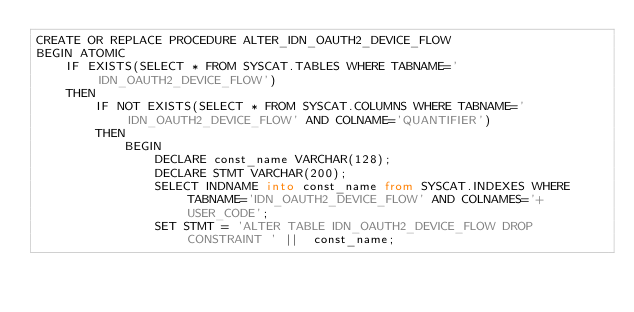Convert code to text. <code><loc_0><loc_0><loc_500><loc_500><_SQL_>CREATE OR REPLACE PROCEDURE ALTER_IDN_OAUTH2_DEVICE_FLOW
BEGIN ATOMIC
    IF EXISTS(SELECT * FROM SYSCAT.TABLES WHERE TABNAME='IDN_OAUTH2_DEVICE_FLOW')
    THEN
        IF NOT EXISTS(SELECT * FROM SYSCAT.COLUMNS WHERE TABNAME='IDN_OAUTH2_DEVICE_FLOW' AND COLNAME='QUANTIFIER')
        THEN
            BEGIN
                DECLARE const_name VARCHAR(128);
                DECLARE STMT VARCHAR(200);
                SELECT INDNAME into const_name from SYSCAT.INDEXES WHERE TABNAME='IDN_OAUTH2_DEVICE_FLOW' AND COLNAMES='+USER_CODE';
                SET STMT = 'ALTER TABLE IDN_OAUTH2_DEVICE_FLOW DROP CONSTRAINT ' ||  const_name;</code> 